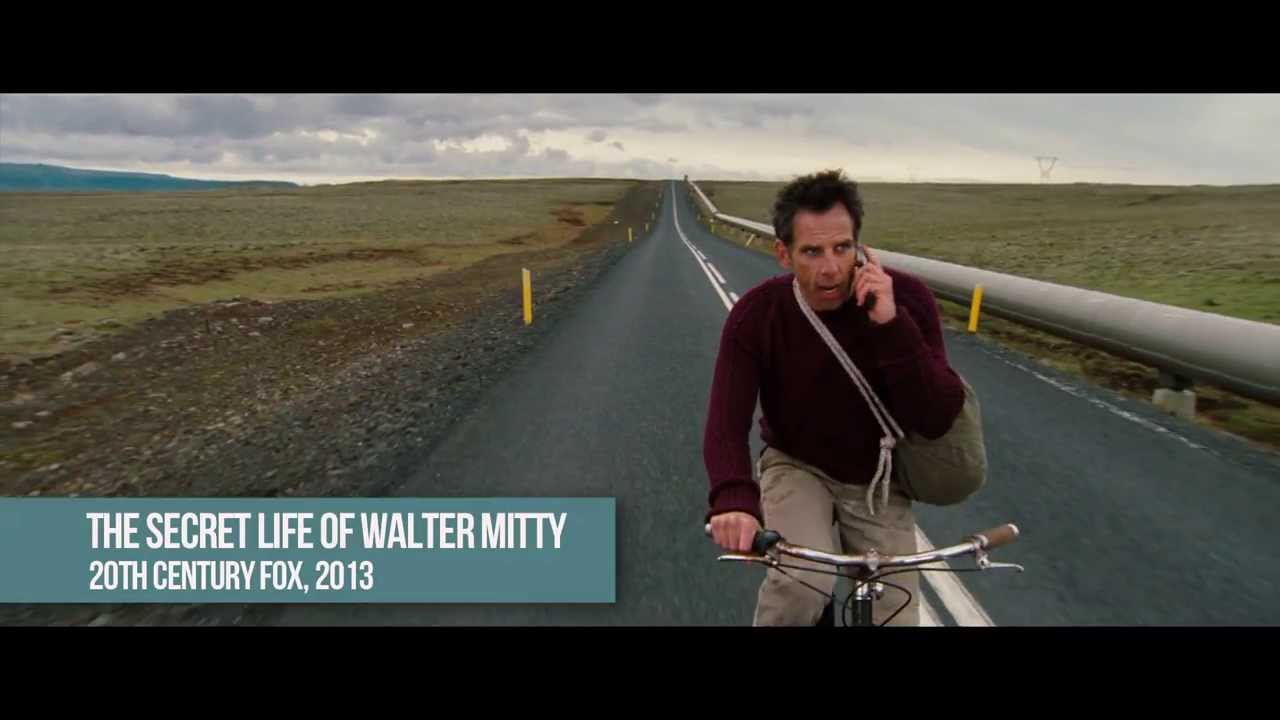Imagine a dialogue between the cyclist and an imaginary friend who appears to him. Start the conversation. Cyclist: 'Why now, of all times? Can't you see I'm in a rush?' 
Imaginary Friend: 'That's exactly why I am here. You need someone to help you navigate through this mess.' 
Cyclist: 'Great, an imaginary friend. Just what I needed. Do you even know where I'm headed?' 
Imaginary Friend: 'I might have some insights. Besides, you look like you could use the company. Why don't you start by telling me what’s in that notebook of yours?' Imaginary Friend: 'And by the way, have you noticed how eerie this place looks?' Cyclist: 'How could I not? It's like the end of the world out here. Every turn, we face another invisible threat. But I have to keep going. Too many lives depend on this.' 
Imaginary Friend: 'I get it, really. But sometimes, taking a step back and thinking might actually speed you up. So, what’s the plan?' 
Cyclist: 'Plan? Ride as fast as I can. Avoid any obstacles. And pray I make it in time.' 